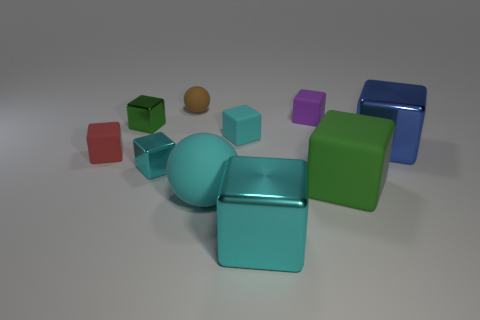Subtract all cyan cubes. How many were subtracted if there are1cyan cubes left? 2 Subtract all red rubber cubes. How many cubes are left? 7 Subtract 6 cubes. How many cubes are left? 2 Add 2 cyan rubber spheres. How many cyan rubber spheres exist? 3 Subtract all blue blocks. How many blocks are left? 7 Subtract 1 brown spheres. How many objects are left? 9 Subtract all blocks. How many objects are left? 2 Subtract all gray cubes. Subtract all green cylinders. How many cubes are left? 8 Subtract all red cylinders. How many blue blocks are left? 1 Subtract all brown spheres. Subtract all blue metal blocks. How many objects are left? 8 